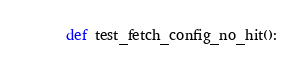<code> <loc_0><loc_0><loc_500><loc_500><_Python_>def test_fetch_config_no_hit():</code> 